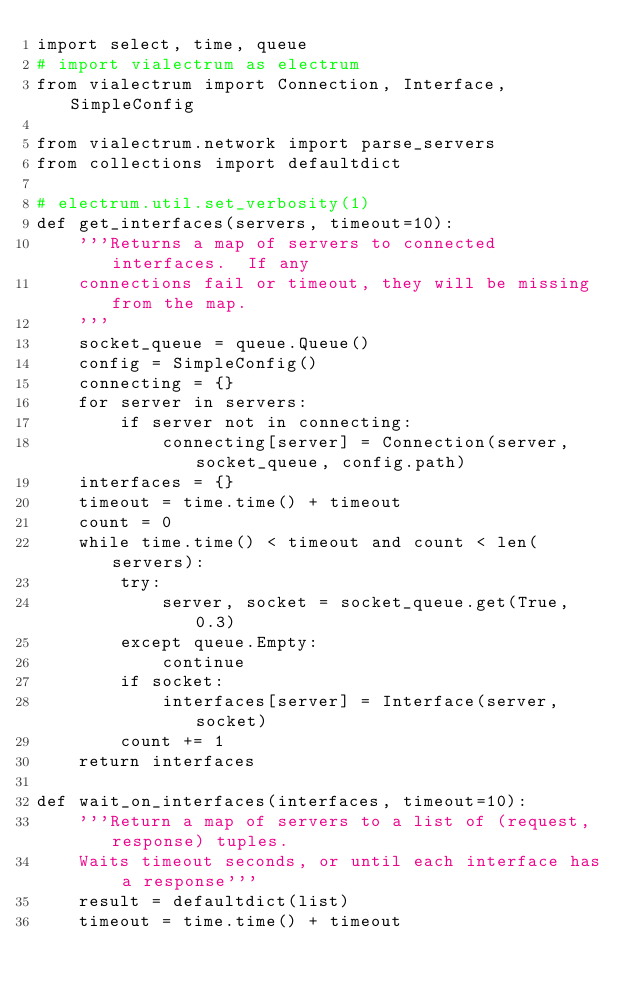Convert code to text. <code><loc_0><loc_0><loc_500><loc_500><_Python_>import select, time, queue
# import vialectrum as electrum
from vialectrum import Connection, Interface, SimpleConfig

from vialectrum.network import parse_servers
from collections import defaultdict

# electrum.util.set_verbosity(1)
def get_interfaces(servers, timeout=10):
    '''Returns a map of servers to connected interfaces.  If any
    connections fail or timeout, they will be missing from the map.
    '''
    socket_queue = queue.Queue()
    config = SimpleConfig()
    connecting = {}
    for server in servers:
        if server not in connecting:
            connecting[server] = Connection(server, socket_queue, config.path)
    interfaces = {}
    timeout = time.time() + timeout
    count = 0
    while time.time() < timeout and count < len(servers):
        try:
            server, socket = socket_queue.get(True, 0.3)
        except queue.Empty:
            continue
        if socket:
            interfaces[server] = Interface(server, socket)
        count += 1
    return interfaces

def wait_on_interfaces(interfaces, timeout=10):
    '''Return a map of servers to a list of (request, response) tuples.
    Waits timeout seconds, or until each interface has a response'''
    result = defaultdict(list)
    timeout = time.time() + timeout</code> 